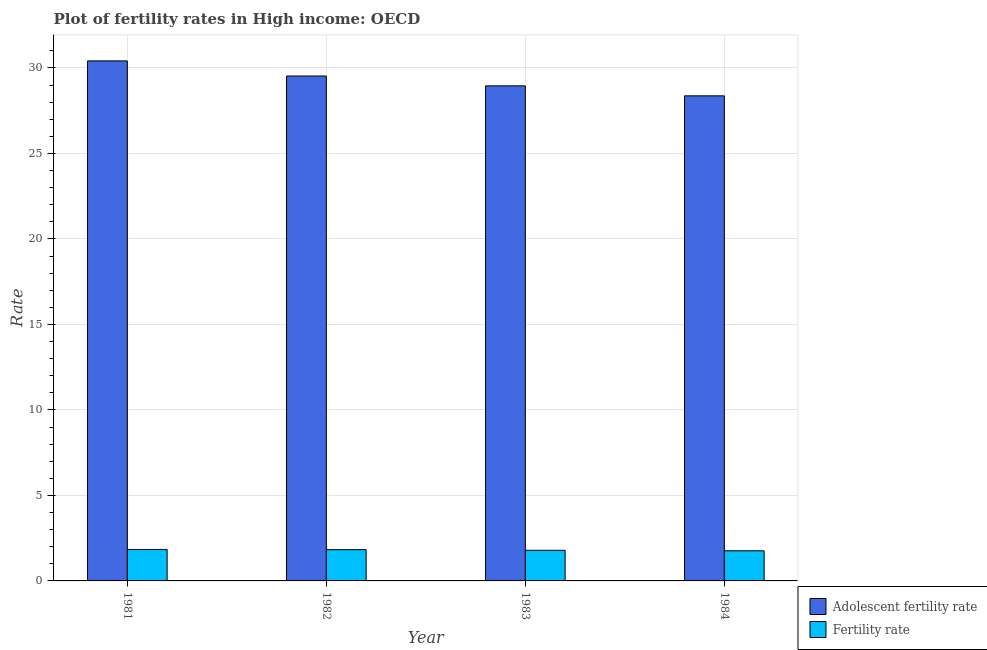How many different coloured bars are there?
Your response must be concise. 2. How many groups of bars are there?
Offer a very short reply. 4. Are the number of bars per tick equal to the number of legend labels?
Provide a short and direct response. Yes. Are the number of bars on each tick of the X-axis equal?
Offer a very short reply. Yes. In how many cases, is the number of bars for a given year not equal to the number of legend labels?
Give a very brief answer. 0. What is the fertility rate in 1984?
Make the answer very short. 1.76. Across all years, what is the maximum fertility rate?
Offer a very short reply. 1.84. Across all years, what is the minimum adolescent fertility rate?
Ensure brevity in your answer.  28.37. What is the total fertility rate in the graph?
Keep it short and to the point. 7.22. What is the difference between the fertility rate in 1982 and that in 1984?
Your answer should be very brief. 0.07. What is the difference between the fertility rate in 1984 and the adolescent fertility rate in 1982?
Give a very brief answer. -0.07. What is the average fertility rate per year?
Offer a terse response. 1.81. In the year 1983, what is the difference between the fertility rate and adolescent fertility rate?
Your answer should be very brief. 0. What is the ratio of the fertility rate in 1981 to that in 1982?
Offer a very short reply. 1.01. Is the difference between the fertility rate in 1982 and 1984 greater than the difference between the adolescent fertility rate in 1982 and 1984?
Ensure brevity in your answer.  No. What is the difference between the highest and the second highest adolescent fertility rate?
Offer a terse response. 0.89. What is the difference between the highest and the lowest fertility rate?
Make the answer very short. 0.08. What does the 2nd bar from the left in 1984 represents?
Make the answer very short. Fertility rate. What does the 2nd bar from the right in 1982 represents?
Your answer should be compact. Adolescent fertility rate. Are all the bars in the graph horizontal?
Offer a terse response. No. How many years are there in the graph?
Provide a succinct answer. 4. Does the graph contain any zero values?
Provide a succinct answer. No. How many legend labels are there?
Make the answer very short. 2. How are the legend labels stacked?
Your answer should be compact. Vertical. What is the title of the graph?
Your answer should be compact. Plot of fertility rates in High income: OECD. Does "Residents" appear as one of the legend labels in the graph?
Make the answer very short. No. What is the label or title of the X-axis?
Your response must be concise. Year. What is the label or title of the Y-axis?
Provide a succinct answer. Rate. What is the Rate in Adolescent fertility rate in 1981?
Offer a terse response. 30.41. What is the Rate of Fertility rate in 1981?
Keep it short and to the point. 1.84. What is the Rate of Adolescent fertility rate in 1982?
Keep it short and to the point. 29.53. What is the Rate of Fertility rate in 1982?
Offer a very short reply. 1.83. What is the Rate in Adolescent fertility rate in 1983?
Make the answer very short. 28.95. What is the Rate of Fertility rate in 1983?
Offer a very short reply. 1.79. What is the Rate of Adolescent fertility rate in 1984?
Ensure brevity in your answer.  28.37. What is the Rate of Fertility rate in 1984?
Provide a succinct answer. 1.76. Across all years, what is the maximum Rate in Adolescent fertility rate?
Your answer should be very brief. 30.41. Across all years, what is the maximum Rate in Fertility rate?
Your answer should be very brief. 1.84. Across all years, what is the minimum Rate of Adolescent fertility rate?
Your answer should be very brief. 28.37. Across all years, what is the minimum Rate in Fertility rate?
Offer a terse response. 1.76. What is the total Rate of Adolescent fertility rate in the graph?
Make the answer very short. 117.27. What is the total Rate of Fertility rate in the graph?
Ensure brevity in your answer.  7.22. What is the difference between the Rate in Adolescent fertility rate in 1981 and that in 1982?
Your answer should be very brief. 0.89. What is the difference between the Rate in Fertility rate in 1981 and that in 1982?
Ensure brevity in your answer.  0.01. What is the difference between the Rate of Adolescent fertility rate in 1981 and that in 1983?
Make the answer very short. 1.46. What is the difference between the Rate of Fertility rate in 1981 and that in 1983?
Offer a very short reply. 0.05. What is the difference between the Rate of Adolescent fertility rate in 1981 and that in 1984?
Your response must be concise. 2.04. What is the difference between the Rate of Fertility rate in 1981 and that in 1984?
Make the answer very short. 0.08. What is the difference between the Rate of Adolescent fertility rate in 1982 and that in 1983?
Keep it short and to the point. 0.58. What is the difference between the Rate of Fertility rate in 1982 and that in 1983?
Keep it short and to the point. 0.04. What is the difference between the Rate of Adolescent fertility rate in 1982 and that in 1984?
Your response must be concise. 1.16. What is the difference between the Rate in Fertility rate in 1982 and that in 1984?
Offer a very short reply. 0.07. What is the difference between the Rate in Adolescent fertility rate in 1983 and that in 1984?
Provide a succinct answer. 0.58. What is the difference between the Rate in Fertility rate in 1983 and that in 1984?
Make the answer very short. 0.03. What is the difference between the Rate in Adolescent fertility rate in 1981 and the Rate in Fertility rate in 1982?
Ensure brevity in your answer.  28.58. What is the difference between the Rate in Adolescent fertility rate in 1981 and the Rate in Fertility rate in 1983?
Give a very brief answer. 28.62. What is the difference between the Rate of Adolescent fertility rate in 1981 and the Rate of Fertility rate in 1984?
Provide a succinct answer. 28.65. What is the difference between the Rate in Adolescent fertility rate in 1982 and the Rate in Fertility rate in 1983?
Make the answer very short. 27.74. What is the difference between the Rate in Adolescent fertility rate in 1982 and the Rate in Fertility rate in 1984?
Provide a succinct answer. 27.77. What is the difference between the Rate of Adolescent fertility rate in 1983 and the Rate of Fertility rate in 1984?
Your response must be concise. 27.19. What is the average Rate of Adolescent fertility rate per year?
Your answer should be compact. 29.32. What is the average Rate in Fertility rate per year?
Give a very brief answer. 1.81. In the year 1981, what is the difference between the Rate of Adolescent fertility rate and Rate of Fertility rate?
Offer a terse response. 28.57. In the year 1982, what is the difference between the Rate of Adolescent fertility rate and Rate of Fertility rate?
Your answer should be compact. 27.7. In the year 1983, what is the difference between the Rate in Adolescent fertility rate and Rate in Fertility rate?
Ensure brevity in your answer.  27.16. In the year 1984, what is the difference between the Rate of Adolescent fertility rate and Rate of Fertility rate?
Make the answer very short. 26.61. What is the ratio of the Rate of Adolescent fertility rate in 1981 to that in 1983?
Provide a succinct answer. 1.05. What is the ratio of the Rate of Fertility rate in 1981 to that in 1983?
Offer a terse response. 1.03. What is the ratio of the Rate in Adolescent fertility rate in 1981 to that in 1984?
Ensure brevity in your answer.  1.07. What is the ratio of the Rate in Fertility rate in 1981 to that in 1984?
Keep it short and to the point. 1.04. What is the ratio of the Rate of Adolescent fertility rate in 1982 to that in 1983?
Provide a short and direct response. 1.02. What is the ratio of the Rate in Fertility rate in 1982 to that in 1983?
Provide a succinct answer. 1.02. What is the ratio of the Rate in Adolescent fertility rate in 1982 to that in 1984?
Your response must be concise. 1.04. What is the ratio of the Rate of Fertility rate in 1982 to that in 1984?
Your answer should be very brief. 1.04. What is the ratio of the Rate of Adolescent fertility rate in 1983 to that in 1984?
Your answer should be compact. 1.02. What is the ratio of the Rate of Fertility rate in 1983 to that in 1984?
Provide a short and direct response. 1.02. What is the difference between the highest and the second highest Rate in Adolescent fertility rate?
Offer a terse response. 0.89. What is the difference between the highest and the second highest Rate of Fertility rate?
Your answer should be very brief. 0.01. What is the difference between the highest and the lowest Rate in Adolescent fertility rate?
Your response must be concise. 2.04. What is the difference between the highest and the lowest Rate in Fertility rate?
Ensure brevity in your answer.  0.08. 